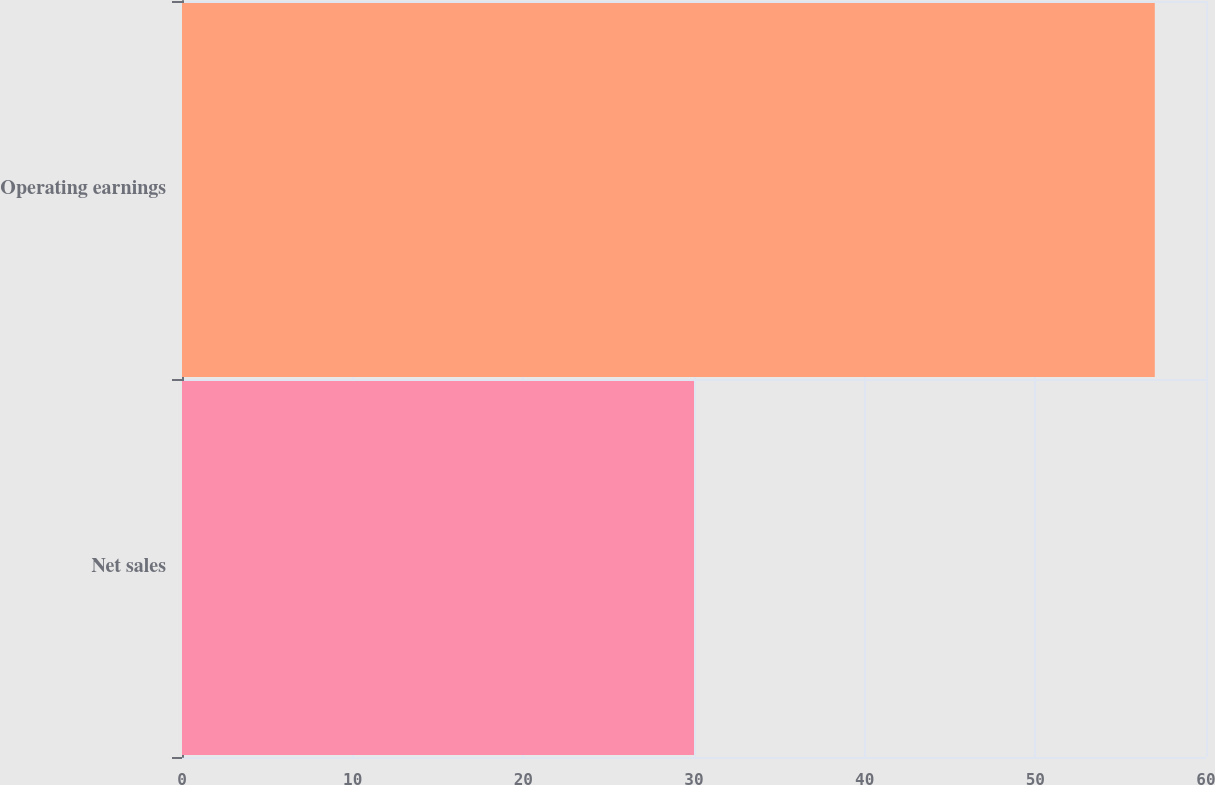Convert chart to OTSL. <chart><loc_0><loc_0><loc_500><loc_500><bar_chart><fcel>Net sales<fcel>Operating earnings<nl><fcel>30<fcel>57<nl></chart> 